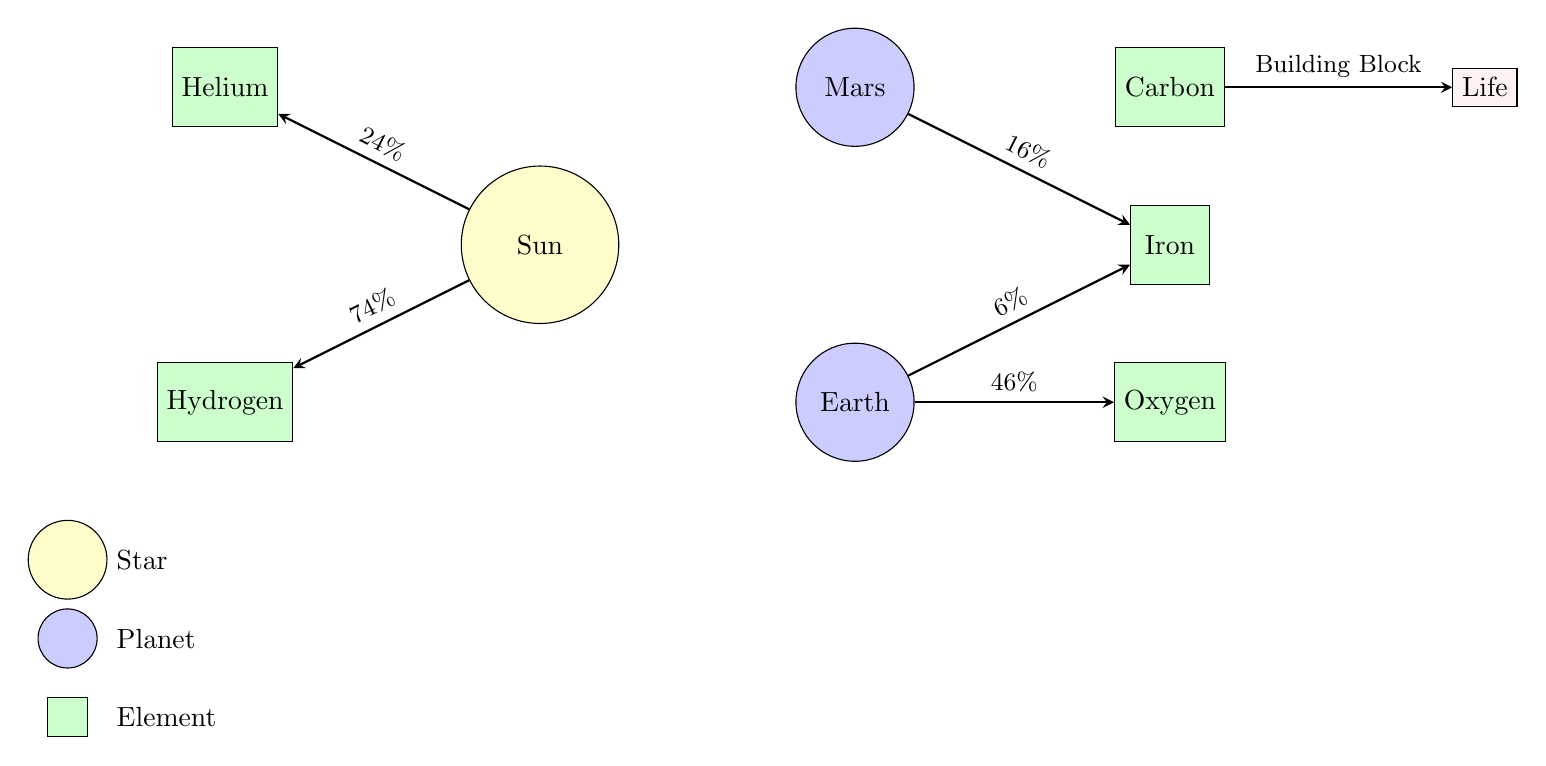What is the percentage of Hydrogen in the Sun? The diagram shows an arrow from the Sun to Hydrogen with the label "74%". This indicates that Hydrogen makes up 74% of the elemental composition of the Sun.
Answer: 74% Which element is represented alongside Helium? The diagram features Helium with an adjacent arrow from the Sun. The only element that appears next to Helium in the diagram is Hydrogen, which is on the left side of the Sun.
Answer: Hydrogen How many planets are depicted in the diagram? The diagram shows two planet nodes, which are Earth and Mars. By counting these nodes, we determine that there are two planets.
Answer: 2 What element has the highest percentage in Earth? Referring to the arrows from Earth, the largest percentage indicated is "46%" connecting to Oxygen. This shows that Oxygen is the most abundant element in Earth as per the diagram.
Answer: Oxygen What type of node is Life? The node labeled "Life" is represented as a rectangle filled with pink color. In the diagram, this indicates that it is categorized differently from the star and planet types.
Answer: Rectangle 